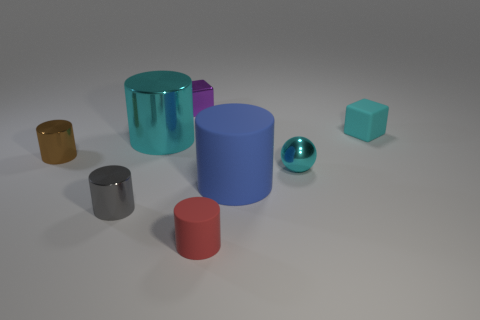Subtract all blue rubber cylinders. How many cylinders are left? 4 Subtract 5 cylinders. How many cylinders are left? 0 Add 1 cylinders. How many objects exist? 9 Subtract all brown cylinders. How many cylinders are left? 4 Add 2 cyan metallic things. How many cyan metallic things are left? 4 Add 4 tiny cyan matte blocks. How many tiny cyan matte blocks exist? 5 Subtract 0 red cubes. How many objects are left? 8 Subtract all spheres. How many objects are left? 7 Subtract all brown spheres. Subtract all cyan cylinders. How many spheres are left? 1 Subtract all purple cylinders. How many purple cubes are left? 1 